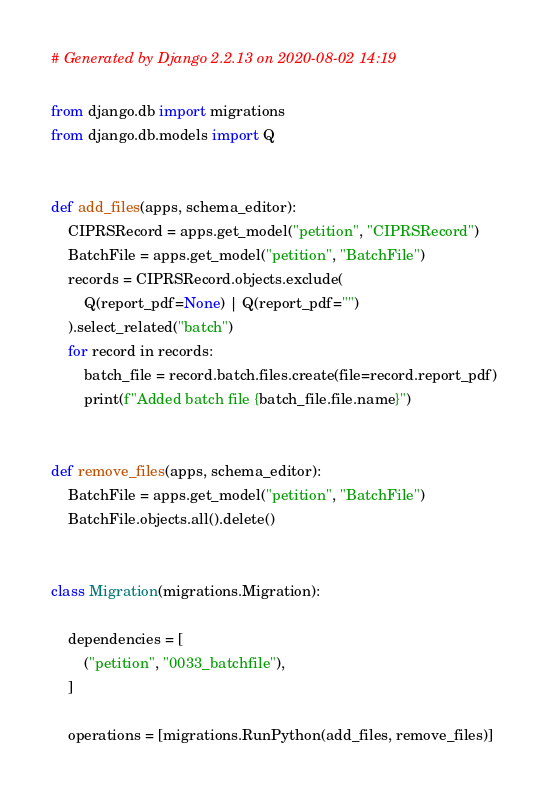Convert code to text. <code><loc_0><loc_0><loc_500><loc_500><_Python_># Generated by Django 2.2.13 on 2020-08-02 14:19

from django.db import migrations
from django.db.models import Q


def add_files(apps, schema_editor):
    CIPRSRecord = apps.get_model("petition", "CIPRSRecord")
    BatchFile = apps.get_model("petition", "BatchFile")
    records = CIPRSRecord.objects.exclude(
        Q(report_pdf=None) | Q(report_pdf="")
    ).select_related("batch")
    for record in records:
        batch_file = record.batch.files.create(file=record.report_pdf)
        print(f"Added batch file {batch_file.file.name}")


def remove_files(apps, schema_editor):
    BatchFile = apps.get_model("petition", "BatchFile")
    BatchFile.objects.all().delete()


class Migration(migrations.Migration):

    dependencies = [
        ("petition", "0033_batchfile"),
    ]

    operations = [migrations.RunPython(add_files, remove_files)]
</code> 